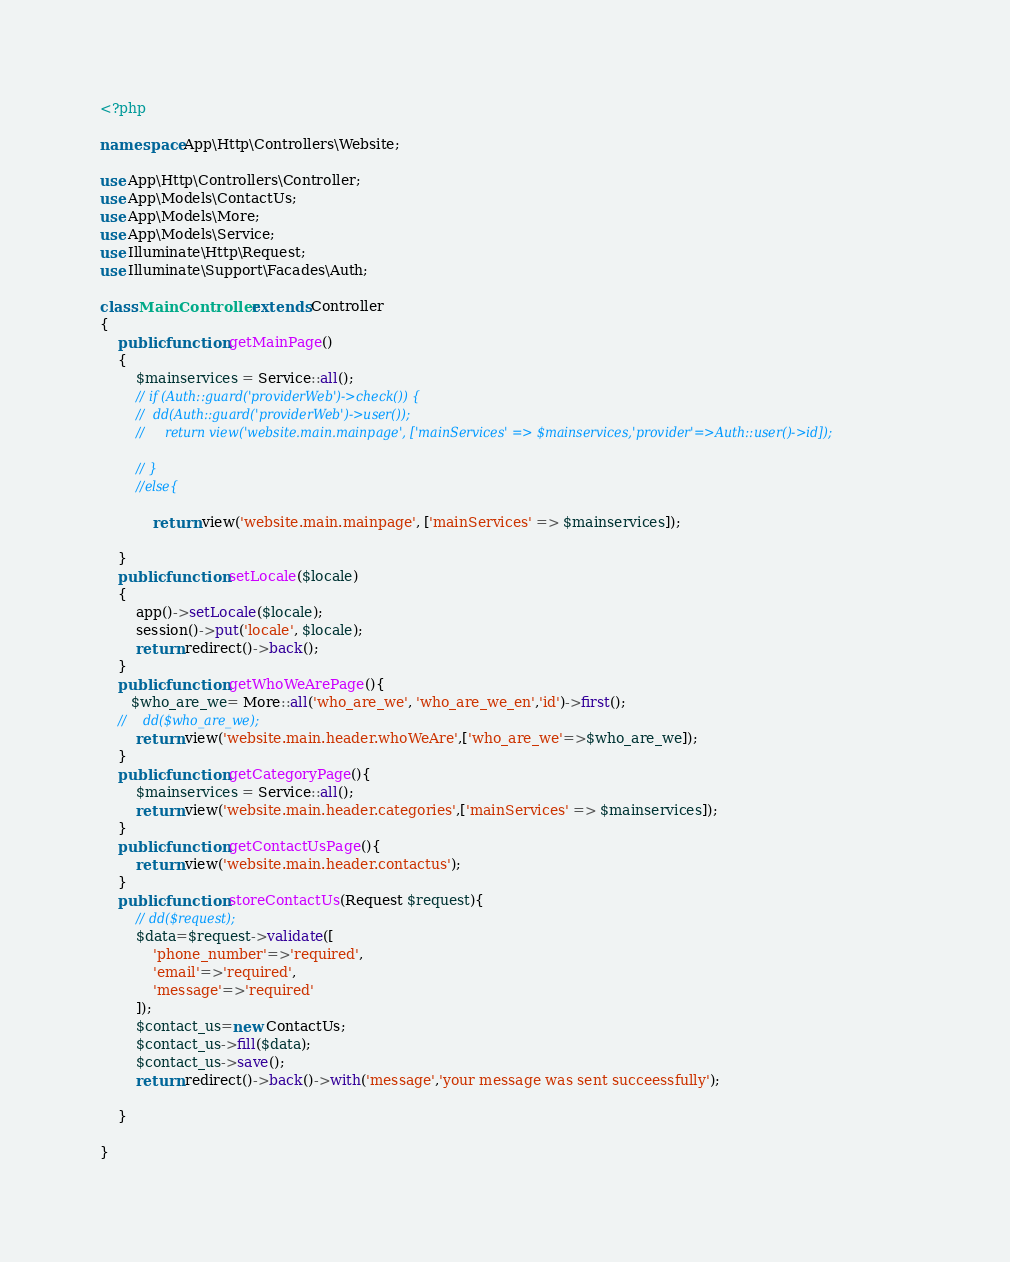<code> <loc_0><loc_0><loc_500><loc_500><_PHP_><?php

namespace App\Http\Controllers\Website;

use App\Http\Controllers\Controller;
use App\Models\ContactUs;
use App\Models\More;
use App\Models\Service;
use Illuminate\Http\Request;
use Illuminate\Support\Facades\Auth;

class MainController extends Controller
{
    public function getMainPage()
    {
        $mainservices = Service::all();
        // if (Auth::guard('providerWeb')->check()) {
        //  dd(Auth::guard('providerWeb')->user());
        //     return view('website.main.mainpage', ['mainServices' => $mainservices,'provider'=>Auth::user()->id]);
  
        // }
        //else{

            return view('website.main.mainpage', ['mainServices' => $mainservices]);
      
    }
    public function setLocale($locale)
    {
        app()->setLocale($locale);
        session()->put('locale', $locale);
        return redirect()->back();
    }
    public function getWhoWeArePage(){
       $who_are_we= More::all('who_are_we', 'who_are_we_en','id')->first();
    //    dd($who_are_we);
        return view('website.main.header.whoWeAre',['who_are_we'=>$who_are_we]);
    }
    public function getCategoryPage(){
        $mainservices = Service::all();
        return view('website.main.header.categories',['mainServices' => $mainservices]);
    }
    public function getContactUsPage(){
        return view('website.main.header.contactus');
    }
    public function storeContactUs(Request $request){
        // dd($request);
        $data=$request->validate([
            'phone_number'=>'required',
            'email'=>'required',
            'message'=>'required'
        ]);
        $contact_us=new ContactUs;
        $contact_us->fill($data);
        $contact_us->save();
        return redirect()->back()->with('message','your message was sent succeessfully');

    }
    
}
</code> 